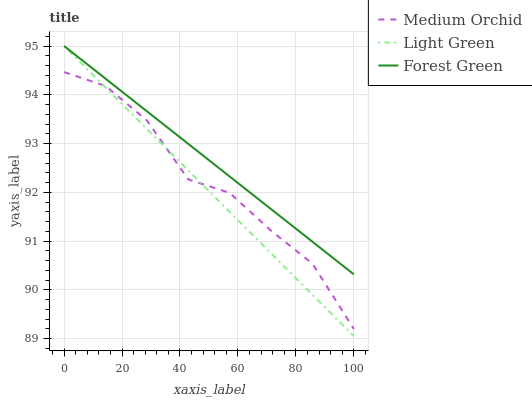Does Light Green have the minimum area under the curve?
Answer yes or no. Yes. Does Forest Green have the maximum area under the curve?
Answer yes or no. Yes. Does Medium Orchid have the minimum area under the curve?
Answer yes or no. No. Does Medium Orchid have the maximum area under the curve?
Answer yes or no. No. Is Forest Green the smoothest?
Answer yes or no. Yes. Is Medium Orchid the roughest?
Answer yes or no. Yes. Is Light Green the smoothest?
Answer yes or no. No. Is Light Green the roughest?
Answer yes or no. No. Does Light Green have the lowest value?
Answer yes or no. Yes. Does Medium Orchid have the lowest value?
Answer yes or no. No. Does Light Green have the highest value?
Answer yes or no. Yes. Does Medium Orchid have the highest value?
Answer yes or no. No. Is Medium Orchid less than Forest Green?
Answer yes or no. Yes. Is Forest Green greater than Medium Orchid?
Answer yes or no. Yes. Does Medium Orchid intersect Light Green?
Answer yes or no. Yes. Is Medium Orchid less than Light Green?
Answer yes or no. No. Is Medium Orchid greater than Light Green?
Answer yes or no. No. Does Medium Orchid intersect Forest Green?
Answer yes or no. No. 